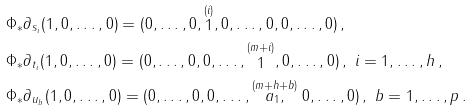<formula> <loc_0><loc_0><loc_500><loc_500>& \Phi _ { * } \partial _ { s _ { i } } ( 1 , 0 , \dots , 0 ) = ( 0 , \dots , 0 , \stackrel { ( i ) } { 1 } , 0 , \dots , 0 , 0 , \dots , 0 ) \, , \\ & \Phi _ { * } \partial _ { t _ { i } } ( 1 , 0 , \dots , 0 ) = ( 0 , \dots , 0 , 0 , \dots , \stackrel { ( m + i ) } { 1 } , 0 , \dots , 0 ) \, , \ i = 1 , \dots , h \, , \\ & \Phi _ { * } \partial _ { u _ { b } } ( 1 , 0 , \dots , 0 ) = ( 0 , \dots , 0 , 0 , \dots , \stackrel { ( m + h + b ) } { a _ { 1 } , } 0 , \dots , 0 ) \, , \ b = 1 , \dots , p \, .</formula> 